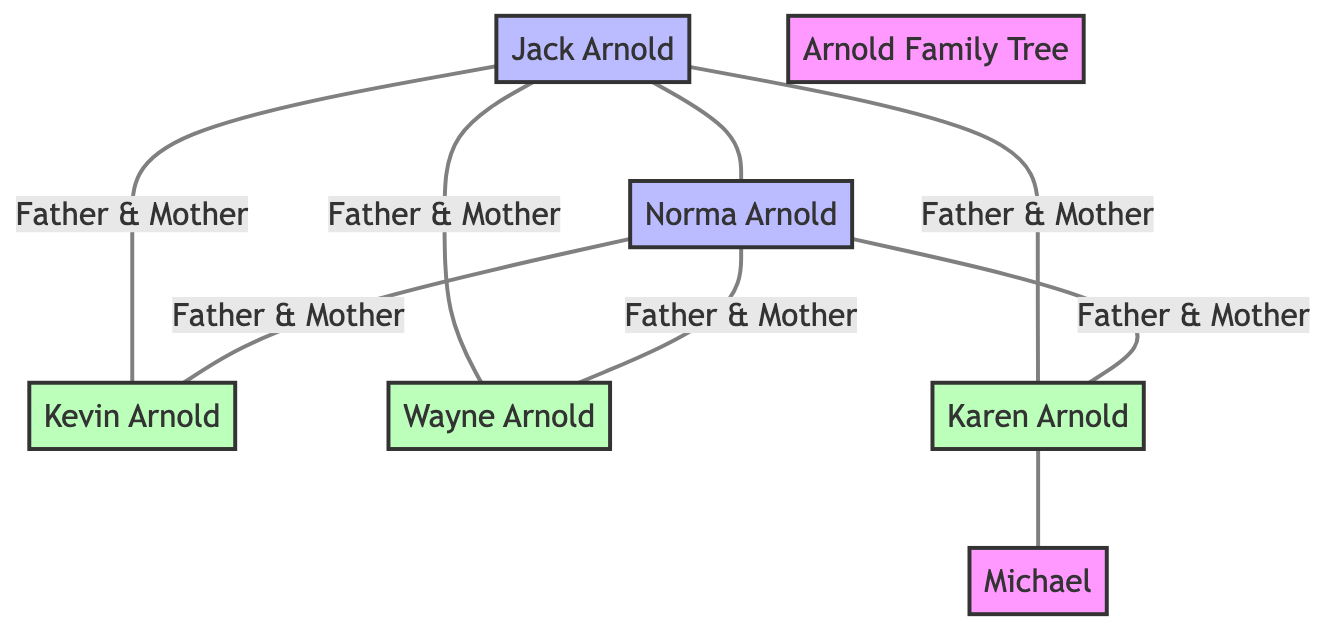What is the name of Kevin's father? The diagram shows that Jack Arnold is listed as the father of Kevin Arnold.
Answer: Jack Arnold How many children do Jack and Norma Arnold have? By counting the number of names listed under the "children" of Jack and Norma Arnold, which are Kevin, Wayne, and Karen, we find that there are three children.
Answer: 3 Who is Karen Arnold married to? The diagram indicates that Karen Arnold has a relationship noted with a spouse named Michael.
Answer: Michael What is the relationship between Wayne Arnold and Norma Arnold? According to the diagram, Wayne Arnold is listed as a son under the parents Jack and Norma Arnold, which means Wayne has a direct relation as Norma's son.
Answer: Son Which member of the Arnold family is a daughter? The diagram specifies that Karen Arnold is denoted as a daughter in the family tree, indicating her gender and parental relationship.
Answer: Karen Arnold If you include spouses, how many members are in the Arnold family? The family tree includes Jack, Norma, Kevin, Wayne, Karen, and Michael (Karen's husband), making a total of six members when counting all of them.
Answer: 6 Who shares the same parents as Kevin Arnold? From the diagram, it is clear that Kevin shares his parents, Jack and Norma Arnold, with Wayne Arnold and Karen Arnold, making them siblings.
Answer: Wayne Arnold, Karen Arnold What type of family tree is presented in the diagram? The diagram represents a family tree specifically illustrating the relationships within the Arnold family, including parents, children, and a spouse.
Answer: Family tree How are Jack and Norma Arnold related to each other? The diagram outlines that Jack Arnold and Norma Arnold are connected by a spouse relationship, indicating they are married.
Answer: Married 